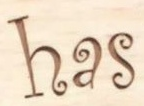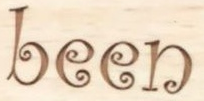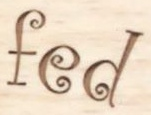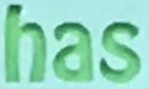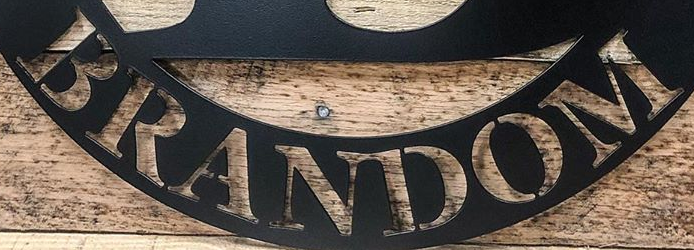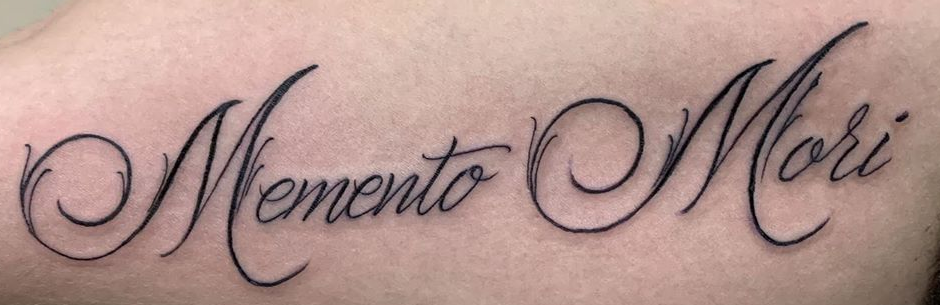What text is displayed in these images sequentially, separated by a semicolon? has; been; fed; has; BRANDOM; MementoMori 